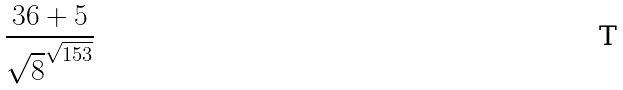<formula> <loc_0><loc_0><loc_500><loc_500>\frac { 3 6 + 5 } { \sqrt { 8 } ^ { \sqrt { 1 5 3 } } }</formula> 